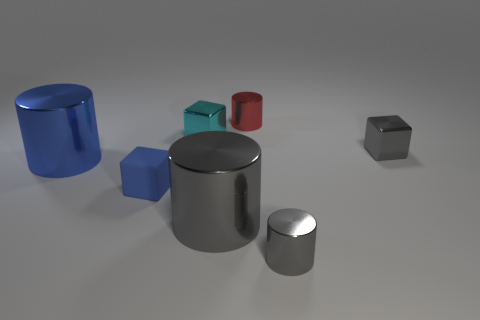Can you tell me what shapes are present in the image and their colors? Certainly! The image features a variety of geometric shapes including a large blue cylinder, a small teal cube, a medium-sized red cylinder, a small matte silver cylinder, and two cubes, one large matte silver and one small shiny black. 